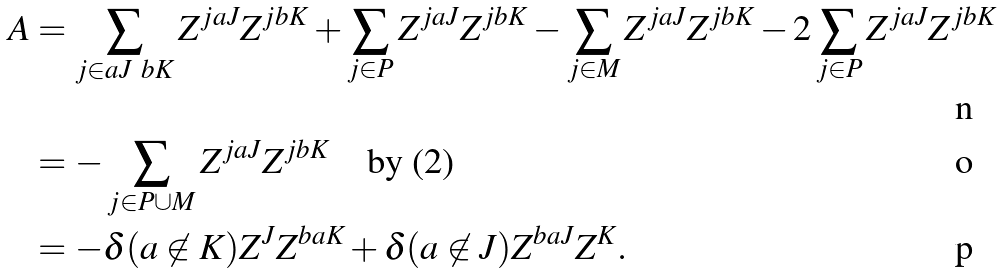Convert formula to latex. <formula><loc_0><loc_0><loc_500><loc_500>A & = \sum _ { j \in a J \ b K } Z ^ { j a J } Z ^ { j b K } + \sum _ { j \in P } Z ^ { j a J } Z ^ { j b K } - \sum _ { j \in M } Z ^ { j a J } Z ^ { j b K } - 2 \sum _ { j \in P } Z ^ { j a J } Z ^ { j b K } \\ & = - \sum _ { j \in P \cup M } Z ^ { j a J } Z ^ { j b K } \quad \text {by (2)} \\ & = - \delta ( a \not \in K ) Z ^ { J } Z ^ { b a K } + \delta ( a \not \in J ) Z ^ { b a J } Z ^ { K } .</formula> 